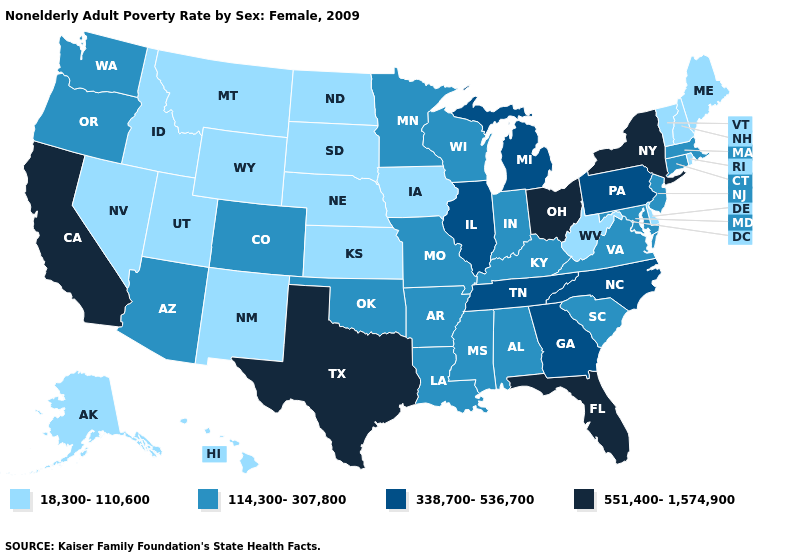Does Nebraska have a lower value than Louisiana?
Answer briefly. Yes. Among the states that border Illinois , does Kentucky have the highest value?
Give a very brief answer. Yes. Name the states that have a value in the range 338,700-536,700?
Keep it brief. Georgia, Illinois, Michigan, North Carolina, Pennsylvania, Tennessee. Name the states that have a value in the range 338,700-536,700?
Keep it brief. Georgia, Illinois, Michigan, North Carolina, Pennsylvania, Tennessee. Does Georgia have the same value as Oregon?
Give a very brief answer. No. Name the states that have a value in the range 338,700-536,700?
Concise answer only. Georgia, Illinois, Michigan, North Carolina, Pennsylvania, Tennessee. What is the value of Delaware?
Be succinct. 18,300-110,600. What is the value of Virginia?
Answer briefly. 114,300-307,800. What is the value of Louisiana?
Write a very short answer. 114,300-307,800. Among the states that border Delaware , which have the highest value?
Give a very brief answer. Pennsylvania. Among the states that border Kentucky , does Illinois have the lowest value?
Answer briefly. No. Name the states that have a value in the range 551,400-1,574,900?
Short answer required. California, Florida, New York, Ohio, Texas. Does Utah have the same value as North Dakota?
Be succinct. Yes. Does the map have missing data?
Be succinct. No. 